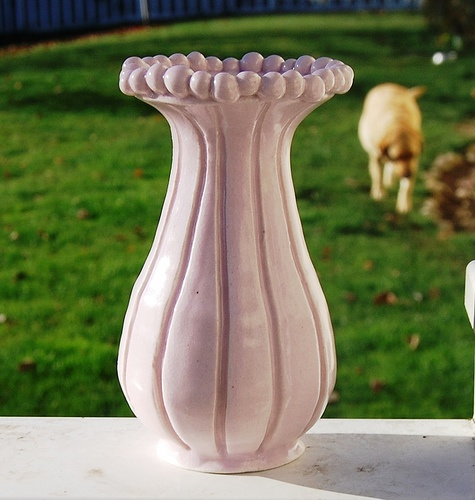Describe the objects in this image and their specific colors. I can see vase in black, darkgray, gray, and lightgray tones and dog in black, tan, and olive tones in this image. 